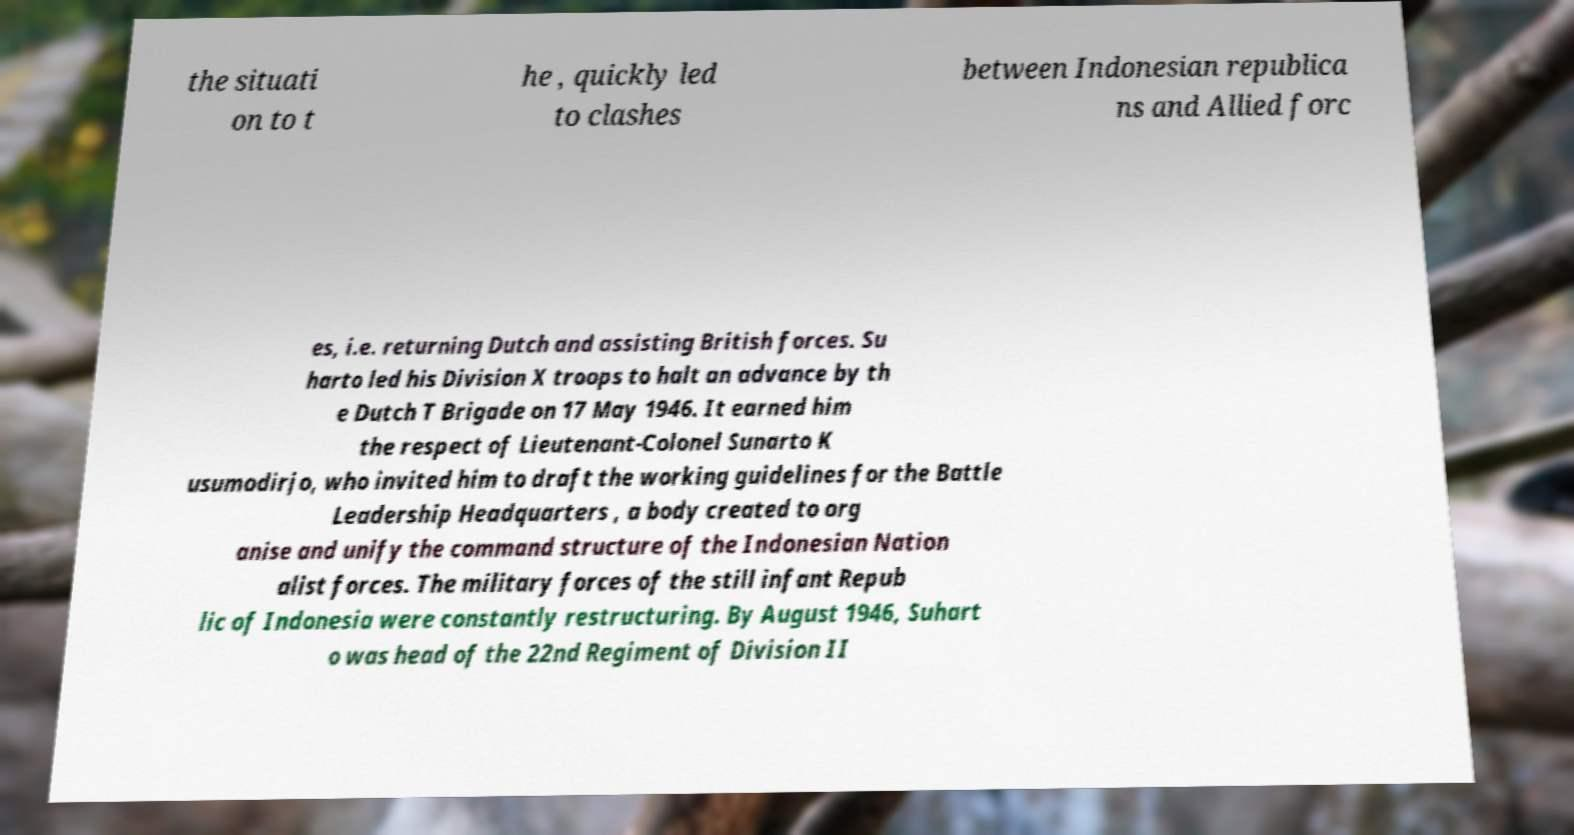Can you accurately transcribe the text from the provided image for me? the situati on to t he , quickly led to clashes between Indonesian republica ns and Allied forc es, i.e. returning Dutch and assisting British forces. Su harto led his Division X troops to halt an advance by th e Dutch T Brigade on 17 May 1946. It earned him the respect of Lieutenant-Colonel Sunarto K usumodirjo, who invited him to draft the working guidelines for the Battle Leadership Headquarters , a body created to org anise and unify the command structure of the Indonesian Nation alist forces. The military forces of the still infant Repub lic of Indonesia were constantly restructuring. By August 1946, Suhart o was head of the 22nd Regiment of Division II 